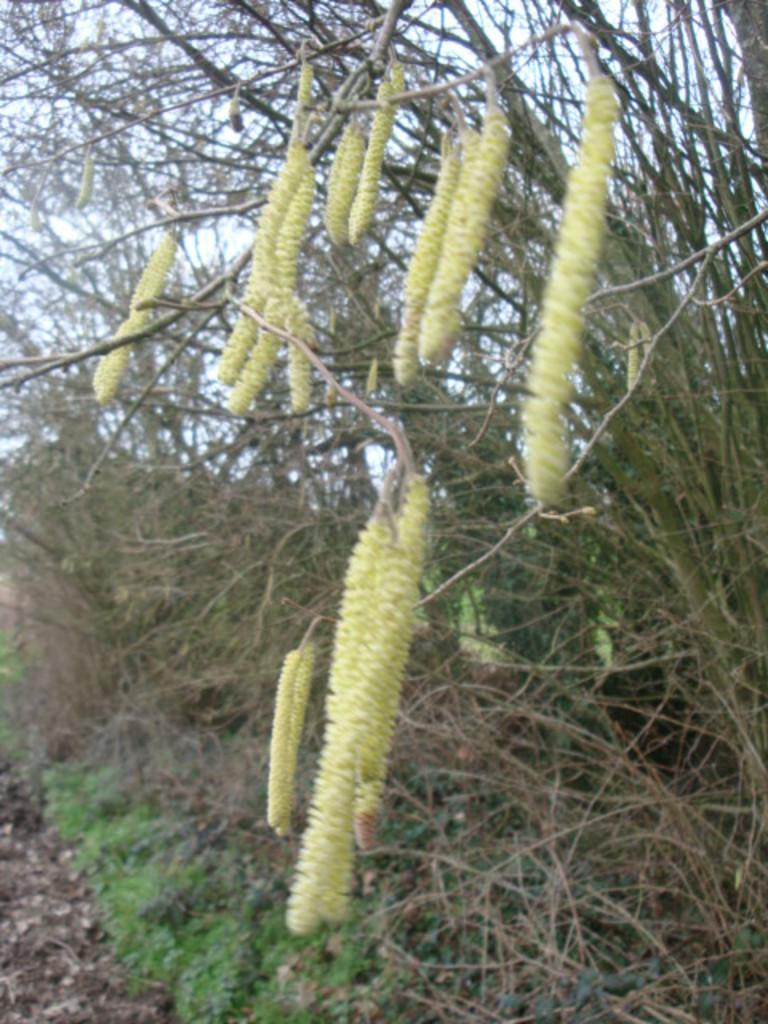Could you give a brief overview of what you see in this image? In the middle of this image, there are white colored flowers of the trees. On the left side, there are plants on the ground. In the background, there are trees and there are clouds in the sky. 